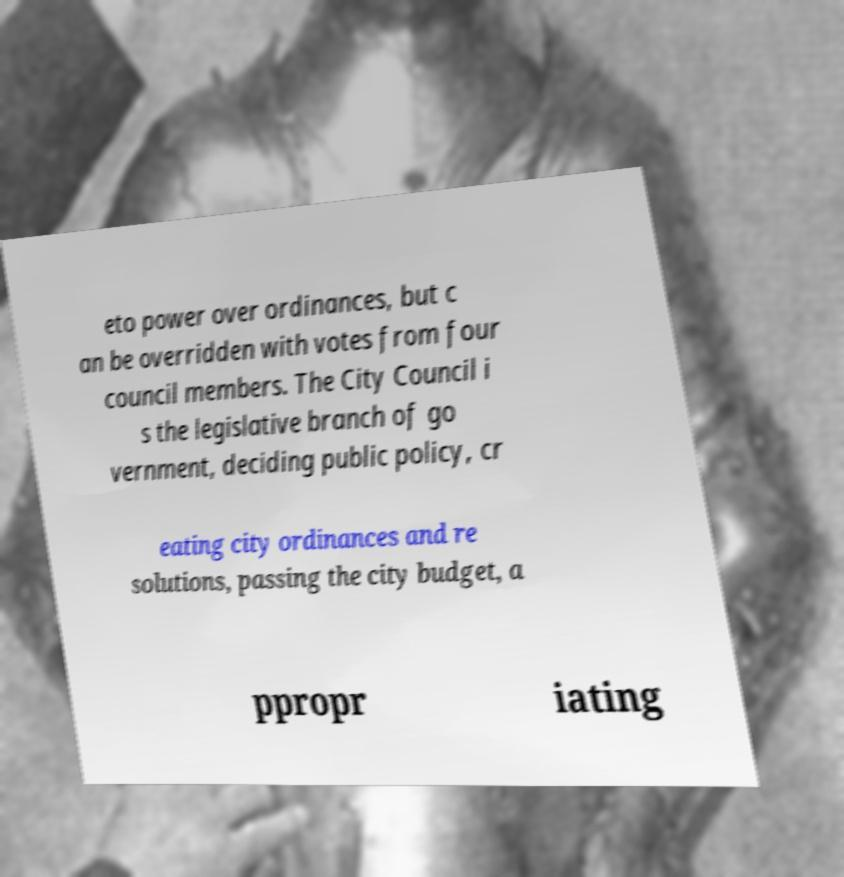There's text embedded in this image that I need extracted. Can you transcribe it verbatim? eto power over ordinances, but c an be overridden with votes from four council members. The City Council i s the legislative branch of go vernment, deciding public policy, cr eating city ordinances and re solutions, passing the city budget, a ppropr iating 